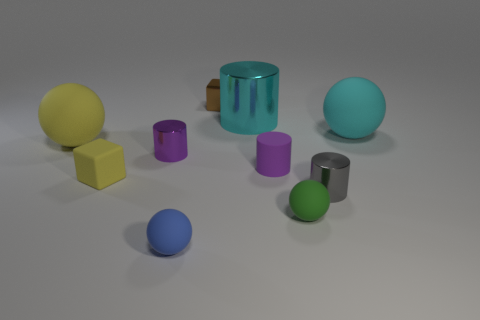Subtract all cylinders. How many objects are left? 6 Add 8 big yellow objects. How many big yellow objects are left? 9 Add 8 purple cylinders. How many purple cylinders exist? 10 Subtract 0 purple blocks. How many objects are left? 10 Subtract all gray things. Subtract all big yellow matte balls. How many objects are left? 8 